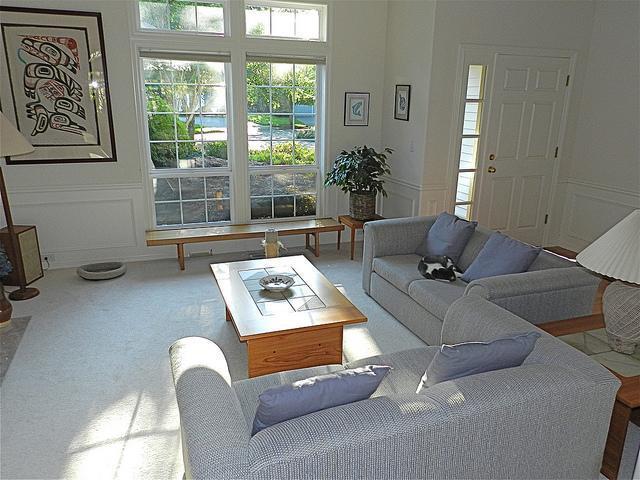How many couches can be seen?
Give a very brief answer. 2. How many people are playing tennis?
Give a very brief answer. 0. 